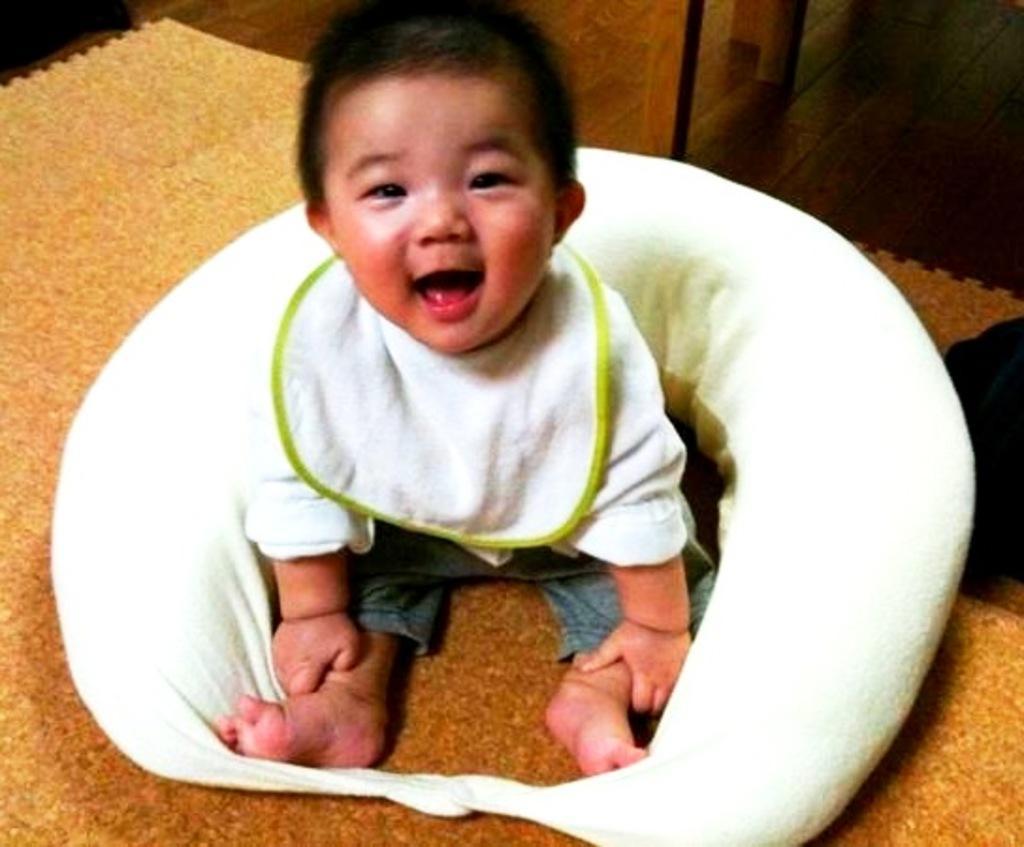Can you describe this image briefly? In this picture we can see a boy sitting on a mat and he is smiling. 